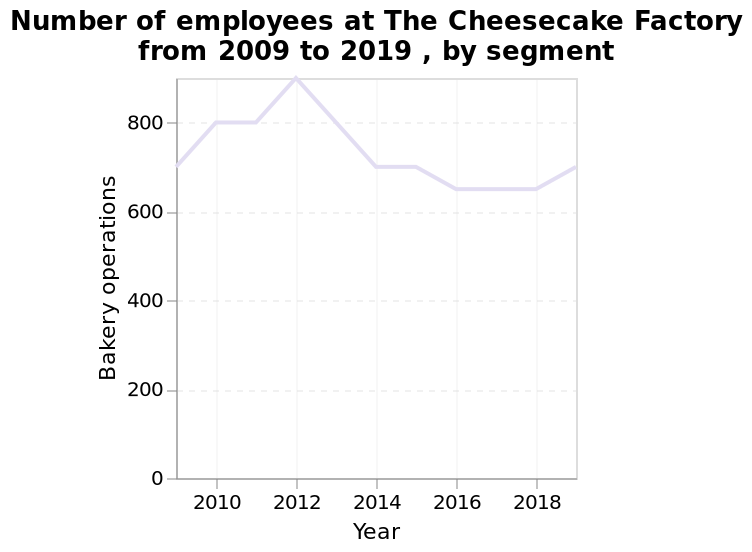<image>
please summary the statistics and relations of the chart The number of employees remains above 600 between 2009 and 2019. 2012 saw the most employees at 900. The lowest number of employees was between 2016 and 2018. After 2018 the number of employees begins to rise again. What is the range of the y-axis for the line graph representing the number of employees in Bakery operations at The Cheesecake Factory? The range of the y-axis for the line graph representing the number of employees in Bakery operations at The Cheesecake Factory is from 0 to 800. 